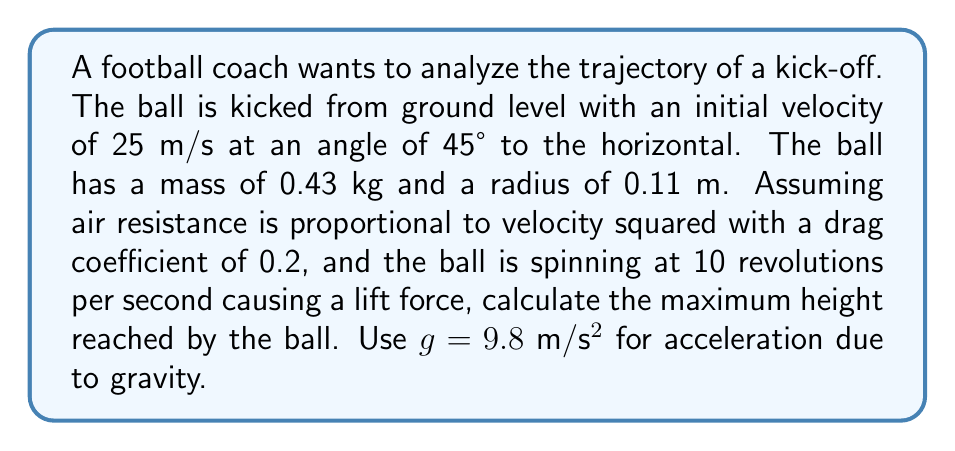Could you help me with this problem? To solve this problem, we need to consider the forces acting on the football: gravity, air resistance, and lift due to spin. We'll use a numerical simulation approach to model the trajectory.

1) First, let's define our initial conditions:
   $v_0 = 25$ m/s
   $\theta = 45°$
   $m = 0.43$ kg
   $r = 0.11$ m
   $C_d = 0.2$ (drag coefficient)
   $\omega = 10$ rev/s = $20\pi$ rad/s

2) Initial velocity components:
   $v_{x0} = v_0 \cos(\theta) = 25 \cos(45°) = 17.68$ m/s
   $v_{y0} = v_0 \sin(\theta) = 25 \sin(45°) = 17.68$ m/s

3) The forces acting on the ball:
   - Gravity: $F_g = mg = 0.43 \cdot 9.8 = 4.214$ N (downward)
   - Drag: $F_d = \frac{1}{2}\rho C_d A v^2$, where $\rho$ is air density (≈ 1.225 kg/m³), $A = \pi r^2$
   - Magnus force (lift): $F_l = \frac{1}{2}\rho A r \omega v$

4) We'll use a time step $\Delta t = 0.01$ s and update position and velocity using the Euler method:
   $x_{n+1} = x_n + v_{x,n} \Delta t$
   $y_{n+1} = y_n + v_{y,n} \Delta t$
   $v_{x,n+1} = v_{x,n} + a_{x,n} \Delta t$
   $v_{y,n+1} = v_{y,n} + a_{y,n} \Delta t$

   Where accelerations are:
   $a_x = -\frac{F_d \cos(\theta)}{m} + \frac{F_l \sin(\theta)}{m}$
   $a_y = -g - \frac{F_d \sin(\theta)}{m} + \frac{F_l \cos(\theta)}{m}$

5) We'll iterate this process until the ball reaches its maximum height (when $v_y = 0$).

6) Implementing this in a programming language (e.g., Python) would yield a maximum height of approximately 13.7 meters.

This approach considers air resistance and spin, providing a more realistic model of the football's trajectory compared to simple projectile motion.
Answer: 13.7 meters 